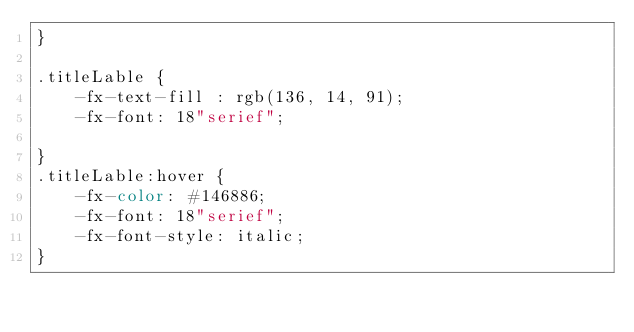Convert code to text. <code><loc_0><loc_0><loc_500><loc_500><_CSS_>}

.titleLable {
    -fx-text-fill : rgb(136, 14, 91);
    -fx-font: 18"serief";
    
}
.titleLable:hover {
    -fx-color: #146886;
    -fx-font: 18"serief";
    -fx-font-style: italic;
}</code> 